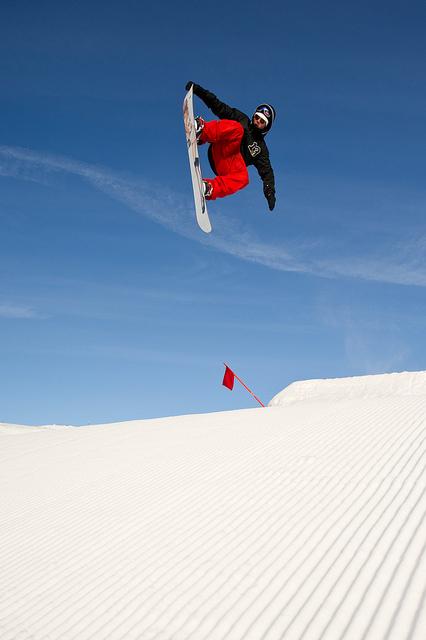Are the man's pants and the flag the same color?
Write a very short answer. Yes. Is there a man flying through the air?
Answer briefly. Yes. At roughly what angle is the flag in the background tilted?
Answer briefly. 45. 